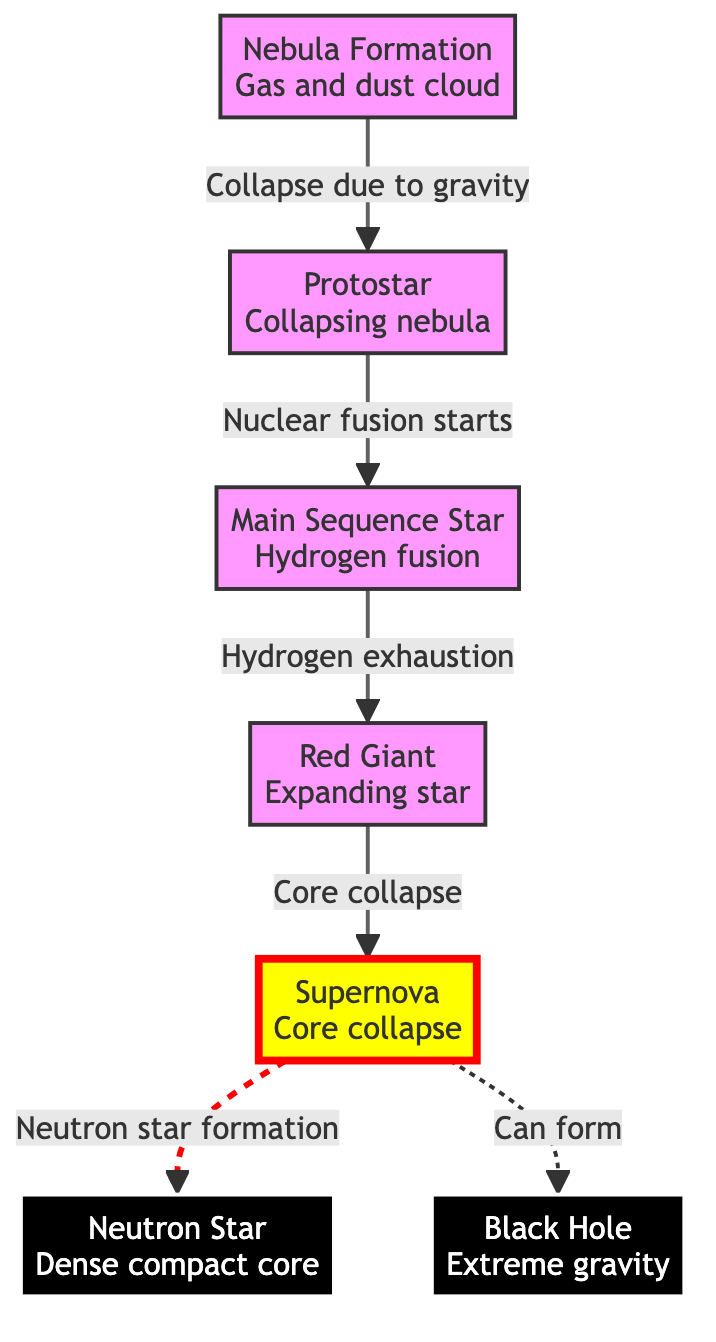What is the first stage of supernova evolution? The first stage of supernova evolution depicted in the diagram is "Nebula Formation", which is indicated at the top of the flow.
Answer: Nebula Formation How many stages are depicted in this diagram? The diagram visually presents a total of seven stages from Nebula Formation to Black Hole, each connected by arrows.
Answer: 7 What event leads from the Red Giant to the Supernova? The transition from Red Giant to Supernova is indicated by "Core collapse", which is shown as the key action that initiates the explosive outcome.
Answer: Core collapse What type of star is formed after a Supernova if it results in a neutron star? The diagram specifies that following a Supernova, if a neutron star is formed, it is described as a "Dense compact core".
Answer: Neutron Star What does the dashed line between the Supernova and Black Hole represent? The dashed line suggests that the formation of a Black Hole can occur after a Supernova under certain conditions, which is indicated by the phrase "Can form".
Answer: Can form What happens after the Protostar stage? According to the diagram, after the Protostar stage, the next stage is reached by "Nuclear fusion starts," leading to the Main Sequence Star.
Answer: Main Sequence Star Which stage of the evolution results in extreme gravity? The diagram shows that the "Black Hole" stage is characterized by "Extreme gravity," highlighting the significant gravitational force associated with this outcome.
Answer: Black Hole What is the relationship between Main Sequence Star and Red Giant? The transition from Main Sequence Star to Red Giant occurs due to "Hydrogen exhaustion," signifying that the star changes after depleting its hydrogen supply.
Answer: Hydrogen exhaustion What is the last stage of the evolution shown in the diagram? The final stage displayed in the diagram after the Supernova is either a Neutron Star or a Black Hole, but specifically, the last one mentioned is "Black Hole".
Answer: Black Hole 